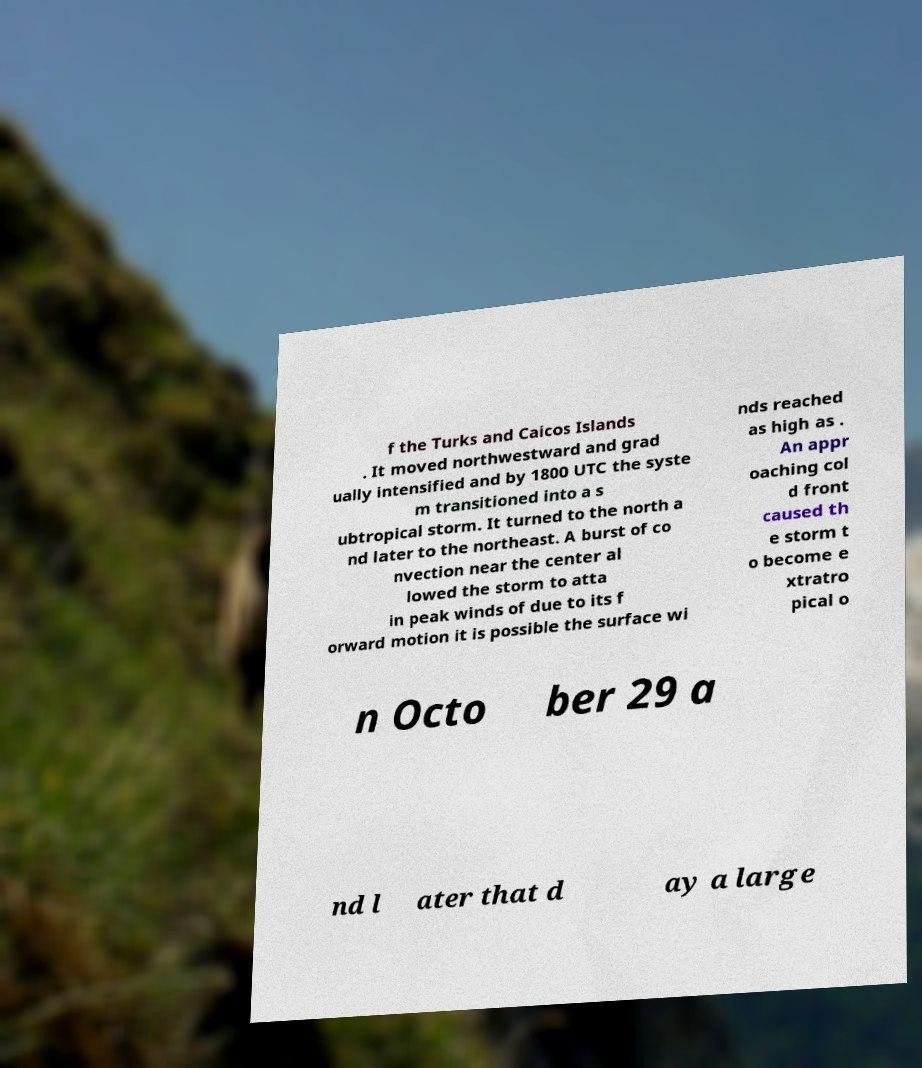Can you read and provide the text displayed in the image?This photo seems to have some interesting text. Can you extract and type it out for me? f the Turks and Caicos Islands . It moved northwestward and grad ually intensified and by 1800 UTC the syste m transitioned into a s ubtropical storm. It turned to the north a nd later to the northeast. A burst of co nvection near the center al lowed the storm to atta in peak winds of due to its f orward motion it is possible the surface wi nds reached as high as . An appr oaching col d front caused th e storm t o become e xtratro pical o n Octo ber 29 a nd l ater that d ay a large 